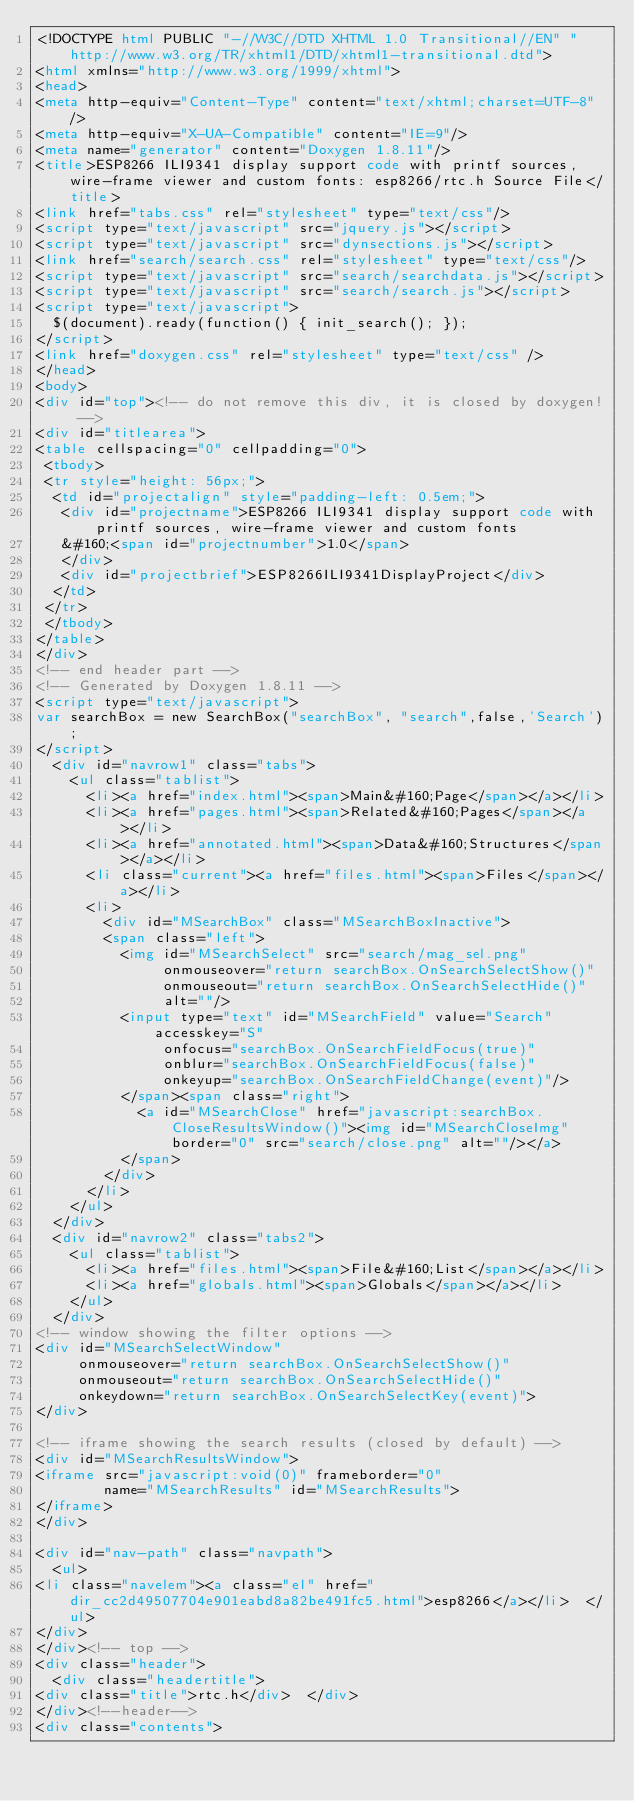<code> <loc_0><loc_0><loc_500><loc_500><_HTML_><!DOCTYPE html PUBLIC "-//W3C//DTD XHTML 1.0 Transitional//EN" "http://www.w3.org/TR/xhtml1/DTD/xhtml1-transitional.dtd">
<html xmlns="http://www.w3.org/1999/xhtml">
<head>
<meta http-equiv="Content-Type" content="text/xhtml;charset=UTF-8"/>
<meta http-equiv="X-UA-Compatible" content="IE=9"/>
<meta name="generator" content="Doxygen 1.8.11"/>
<title>ESP8266 ILI9341 display support code with printf sources, wire-frame viewer and custom fonts: esp8266/rtc.h Source File</title>
<link href="tabs.css" rel="stylesheet" type="text/css"/>
<script type="text/javascript" src="jquery.js"></script>
<script type="text/javascript" src="dynsections.js"></script>
<link href="search/search.css" rel="stylesheet" type="text/css"/>
<script type="text/javascript" src="search/searchdata.js"></script>
<script type="text/javascript" src="search/search.js"></script>
<script type="text/javascript">
  $(document).ready(function() { init_search(); });
</script>
<link href="doxygen.css" rel="stylesheet" type="text/css" />
</head>
<body>
<div id="top"><!-- do not remove this div, it is closed by doxygen! -->
<div id="titlearea">
<table cellspacing="0" cellpadding="0">
 <tbody>
 <tr style="height: 56px;">
  <td id="projectalign" style="padding-left: 0.5em;">
   <div id="projectname">ESP8266 ILI9341 display support code with printf sources, wire-frame viewer and custom fonts
   &#160;<span id="projectnumber">1.0</span>
   </div>
   <div id="projectbrief">ESP8266ILI9341DisplayProject</div>
  </td>
 </tr>
 </tbody>
</table>
</div>
<!-- end header part -->
<!-- Generated by Doxygen 1.8.11 -->
<script type="text/javascript">
var searchBox = new SearchBox("searchBox", "search",false,'Search');
</script>
  <div id="navrow1" class="tabs">
    <ul class="tablist">
      <li><a href="index.html"><span>Main&#160;Page</span></a></li>
      <li><a href="pages.html"><span>Related&#160;Pages</span></a></li>
      <li><a href="annotated.html"><span>Data&#160;Structures</span></a></li>
      <li class="current"><a href="files.html"><span>Files</span></a></li>
      <li>
        <div id="MSearchBox" class="MSearchBoxInactive">
        <span class="left">
          <img id="MSearchSelect" src="search/mag_sel.png"
               onmouseover="return searchBox.OnSearchSelectShow()"
               onmouseout="return searchBox.OnSearchSelectHide()"
               alt=""/>
          <input type="text" id="MSearchField" value="Search" accesskey="S"
               onfocus="searchBox.OnSearchFieldFocus(true)" 
               onblur="searchBox.OnSearchFieldFocus(false)" 
               onkeyup="searchBox.OnSearchFieldChange(event)"/>
          </span><span class="right">
            <a id="MSearchClose" href="javascript:searchBox.CloseResultsWindow()"><img id="MSearchCloseImg" border="0" src="search/close.png" alt=""/></a>
          </span>
        </div>
      </li>
    </ul>
  </div>
  <div id="navrow2" class="tabs2">
    <ul class="tablist">
      <li><a href="files.html"><span>File&#160;List</span></a></li>
      <li><a href="globals.html"><span>Globals</span></a></li>
    </ul>
  </div>
<!-- window showing the filter options -->
<div id="MSearchSelectWindow"
     onmouseover="return searchBox.OnSearchSelectShow()"
     onmouseout="return searchBox.OnSearchSelectHide()"
     onkeydown="return searchBox.OnSearchSelectKey(event)">
</div>

<!-- iframe showing the search results (closed by default) -->
<div id="MSearchResultsWindow">
<iframe src="javascript:void(0)" frameborder="0" 
        name="MSearchResults" id="MSearchResults">
</iframe>
</div>

<div id="nav-path" class="navpath">
  <ul>
<li class="navelem"><a class="el" href="dir_cc2d49507704e901eabd8a82be491fc5.html">esp8266</a></li>  </ul>
</div>
</div><!-- top -->
<div class="header">
  <div class="headertitle">
<div class="title">rtc.h</div>  </div>
</div><!--header-->
<div class="contents"></code> 